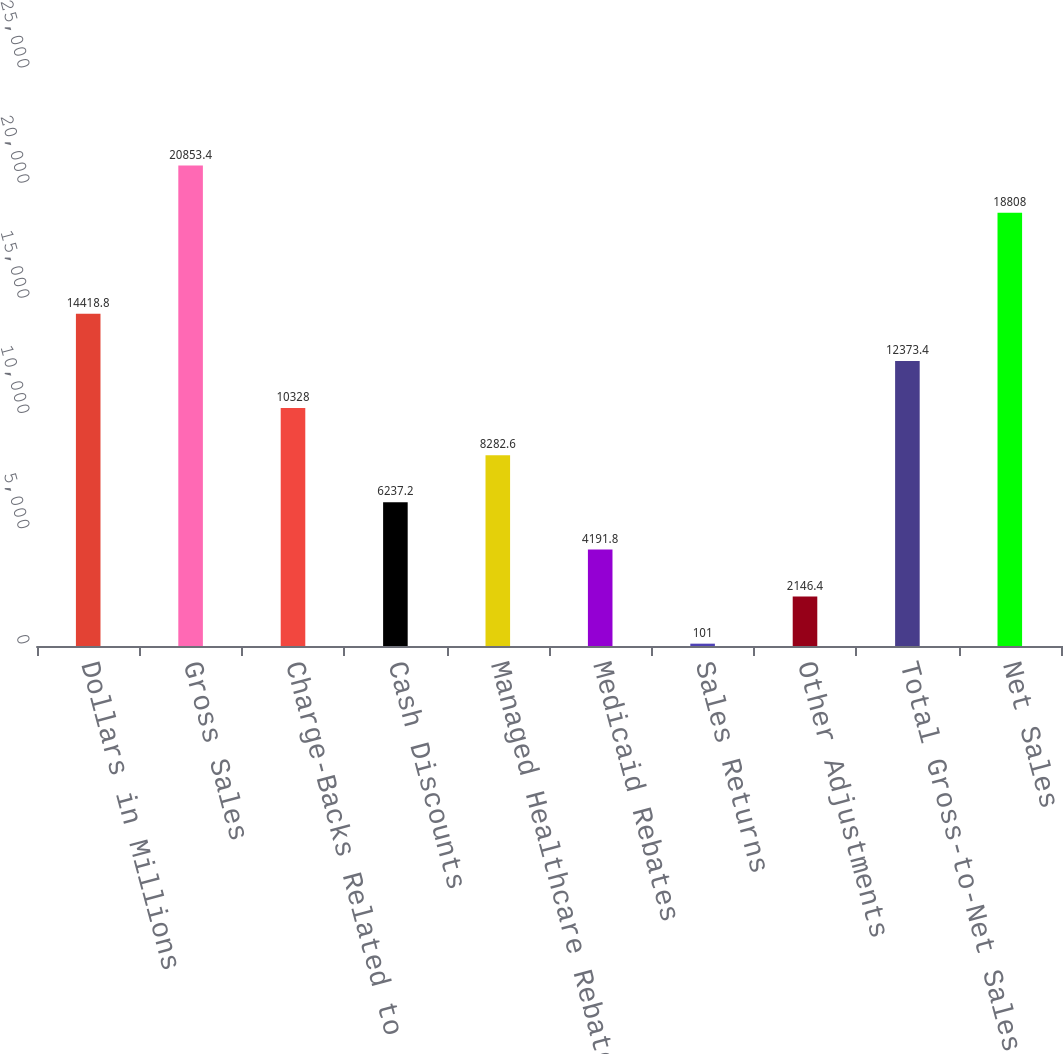Convert chart to OTSL. <chart><loc_0><loc_0><loc_500><loc_500><bar_chart><fcel>Dollars in Millions<fcel>Gross Sales<fcel>Charge-Backs Related to<fcel>Cash Discounts<fcel>Managed Healthcare Rebates and<fcel>Medicaid Rebates<fcel>Sales Returns<fcel>Other Adjustments<fcel>Total Gross-to-Net Sales<fcel>Net Sales<nl><fcel>14418.8<fcel>20853.4<fcel>10328<fcel>6237.2<fcel>8282.6<fcel>4191.8<fcel>101<fcel>2146.4<fcel>12373.4<fcel>18808<nl></chart> 